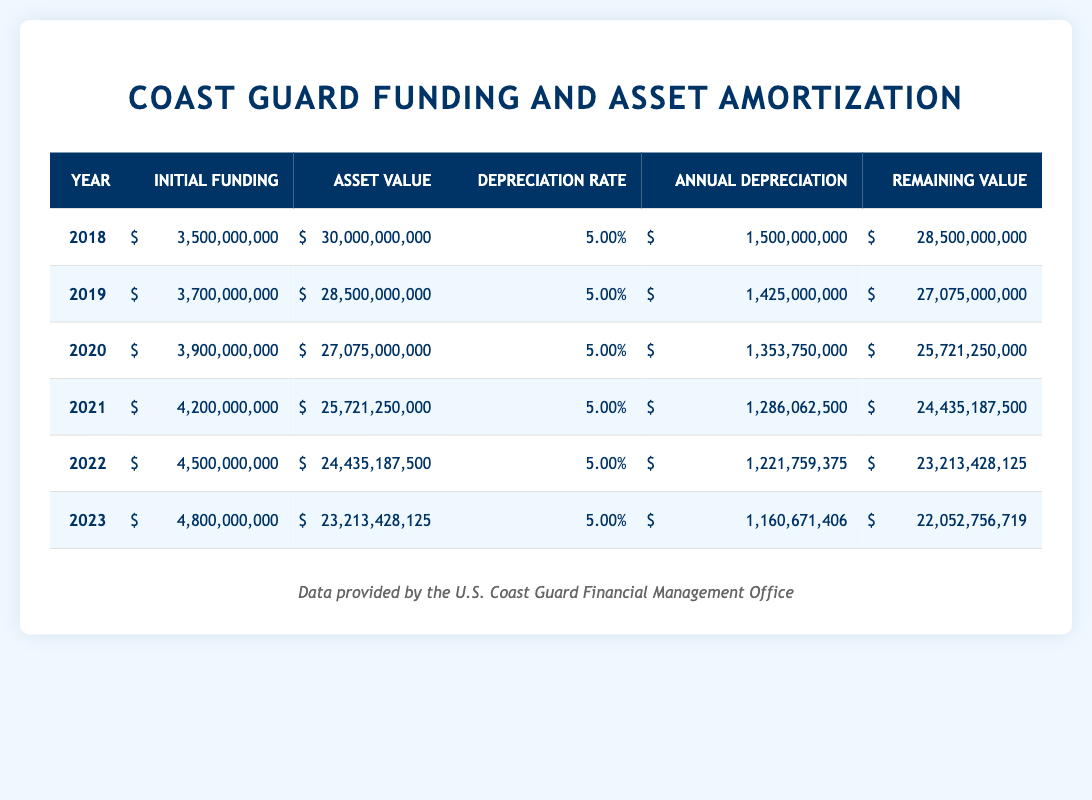What was the total initial funding for the Coast Guard from 2018 to 2023? To calculate the total initial funding from 2018 to 2023, we sum the initial funding amounts for each year: 3,500,000,000 + 3,700,000,000 + 3,900,000,000 + 4,200,000,000 + 4,500,000,000 + 4,800,000,000 = 24,600,000,000.
Answer: 24,600,000,000 What was the annual depreciation for the year with the highest initial funding? The highest initial funding is for the year 2023, which is 4,800,000,000. The annual depreciation for that year is 1,160,671,406.
Answer: 1,160,671,406 Is it true that the asset value decreased with each passing year? Yes, by observing the 'Asset Value' column, it is evident that the asset value decreased each year: 30,000,000,000 in 2018 to 22,052,756,719 in 2023.
Answer: Yes What is the percentage of the remaining value compared to the initial asset value in 2022? To calculate this percentage, we take the remaining value for 2022, which is 23,213,428,125, and divide it by the initial asset value, which is 30,000,000,000, resulting in (23,213,428,125 / 30,000,000,000) * 100 = 77.38%.
Answer: 77.38% How much total depreciation occurred from 2018 to 2023? To find the total depreciation, we sum the annual depreciation for each year: 1,500,000,000 + 1,425,000,000 + 1,353,750,000 + 1,286,062,500 + 1,221,759,375 + 1,160,671,406 = 7,947,243,281.
Answer: 7,947,243,281 What was the initial funding in 2021 compared to the depreciation for that year? The initial funding in 2021 is 4,200,000,000, and the annual depreciation for that year is 1,286,062,500. By comparing these values, we see that the initial funding is significantly higher than the depreciation.
Answer: 4,200,000,000 Which year had the largest decrease in asset value, and by how much? The largest decrease in asset value occurred from 2018 to 2019, where the asset value dropped from 30,000,000,000 to 28,500,000,000, a decrease of 1,500,000,000.
Answer: 1,500,000,000 Did the depreciation rate remain consistent throughout the years presented? Yes, the depreciation rate remained constant at 5.00% for each year from 2018 to 2023.
Answer: Yes 